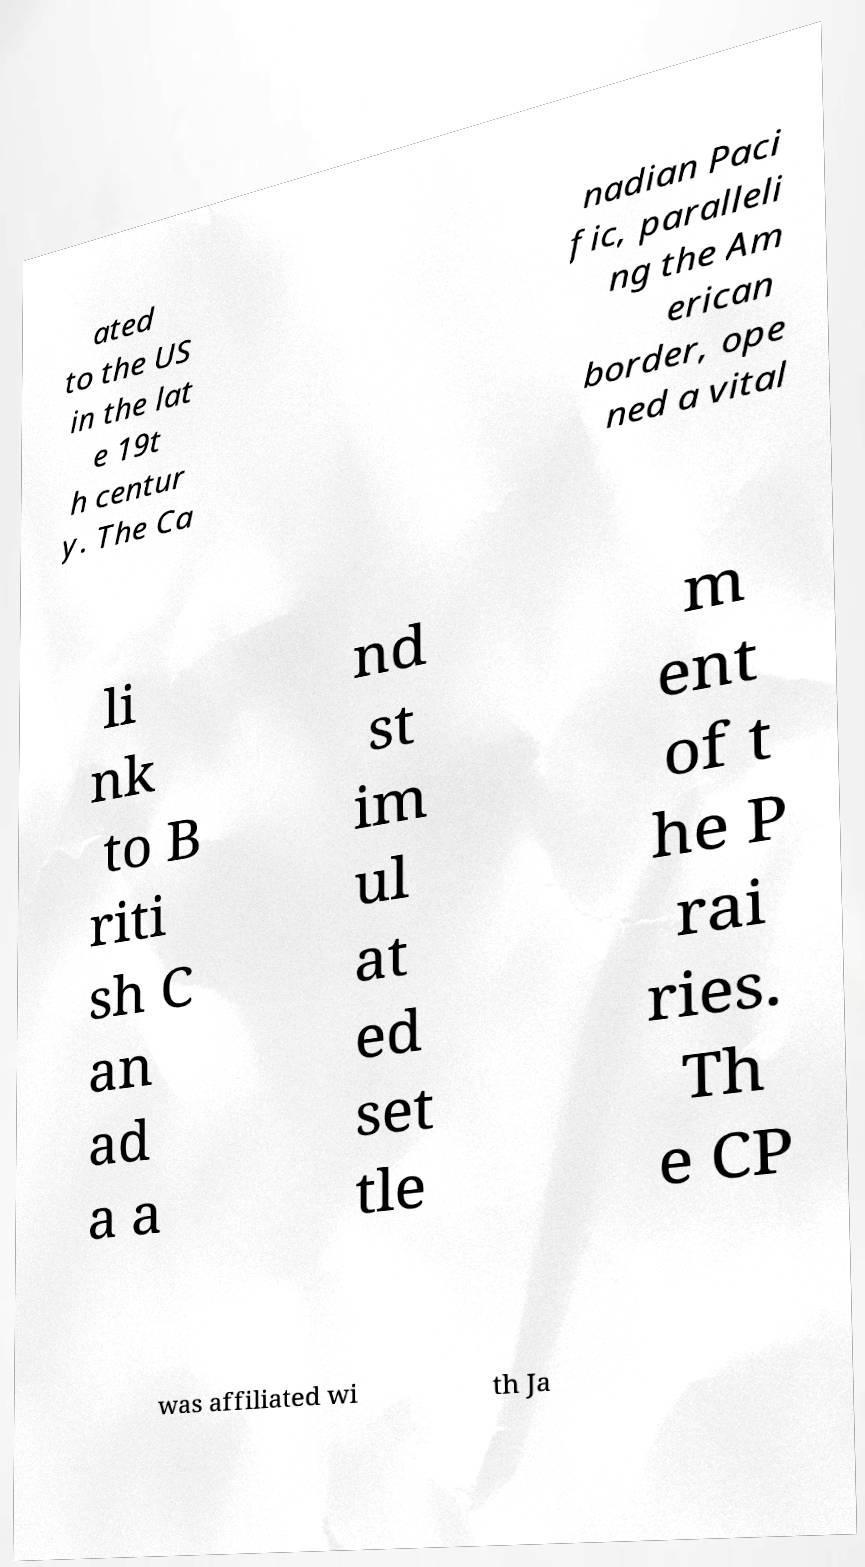Can you read and provide the text displayed in the image?This photo seems to have some interesting text. Can you extract and type it out for me? ated to the US in the lat e 19t h centur y. The Ca nadian Paci fic, paralleli ng the Am erican border, ope ned a vital li nk to B riti sh C an ad a a nd st im ul at ed set tle m ent of t he P rai ries. Th e CP was affiliated wi th Ja 